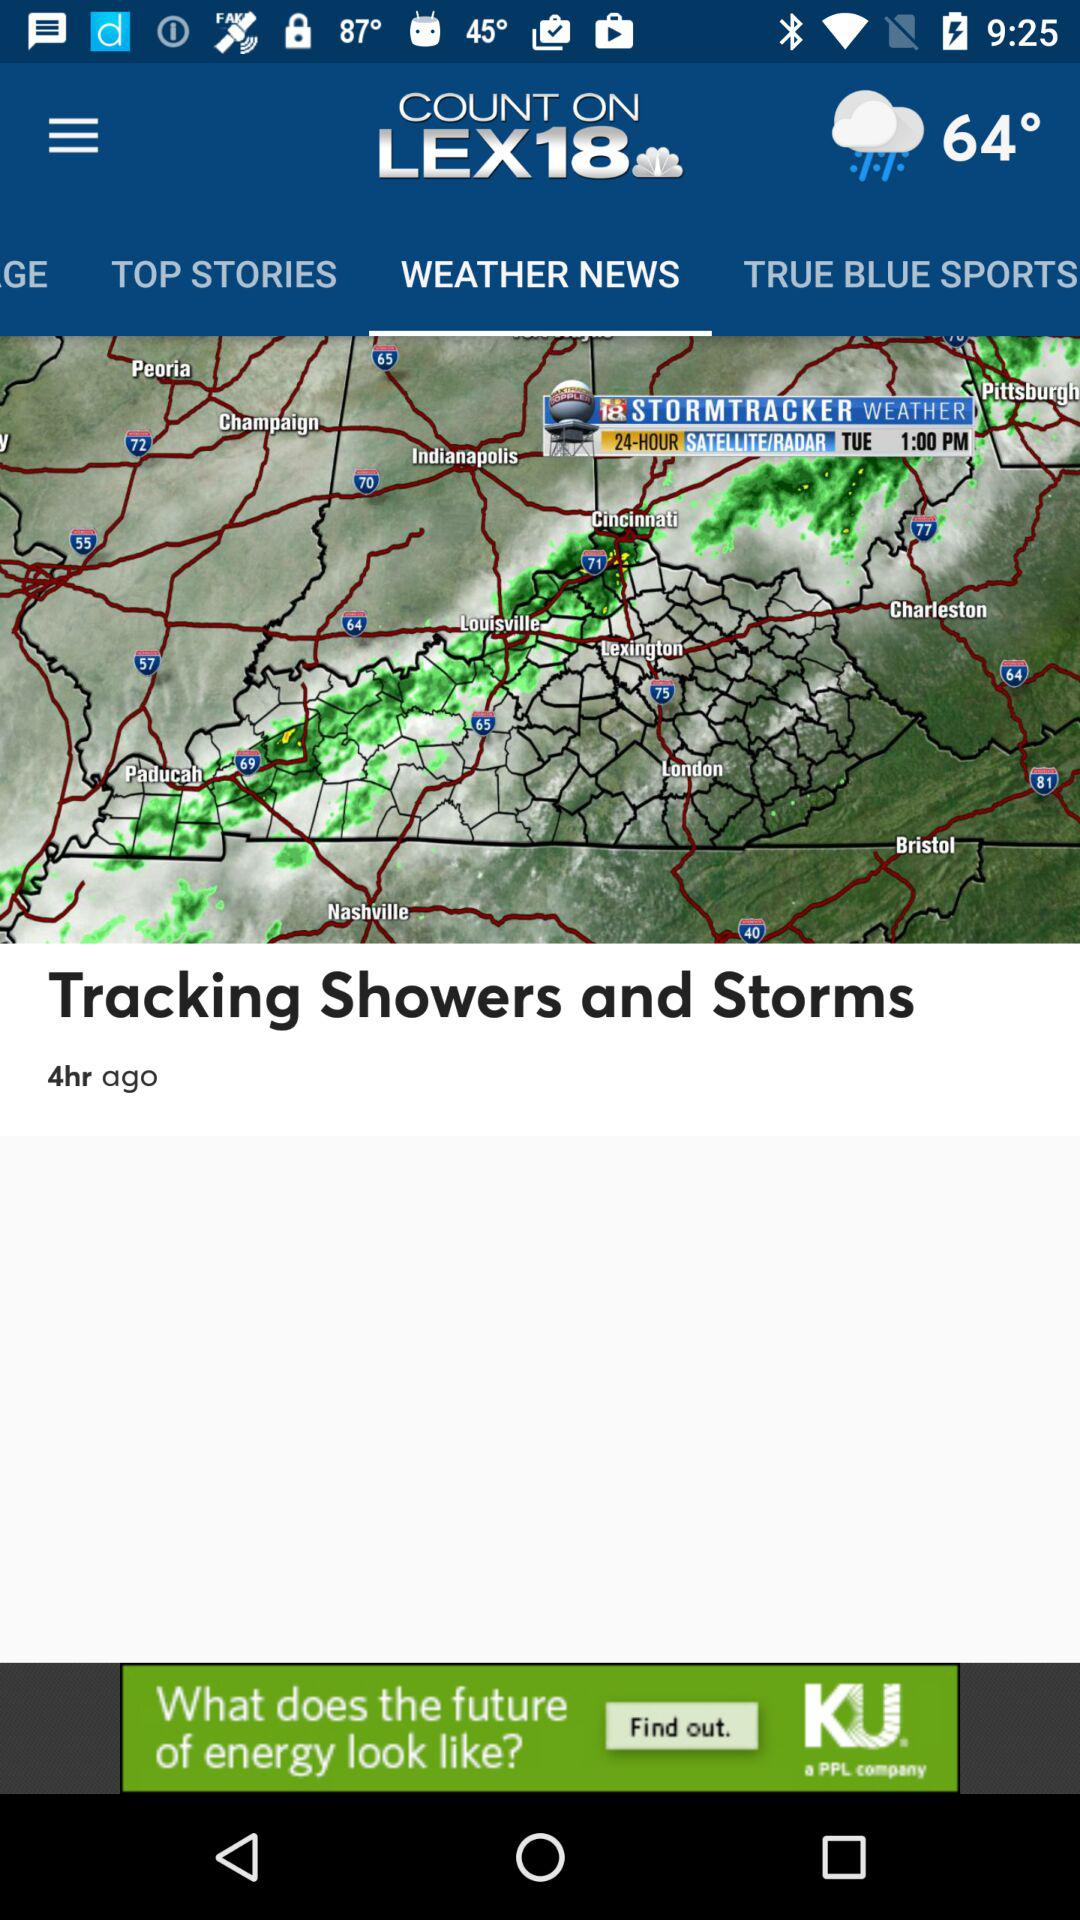Which tab am I on? You are on the tab "WEATHER NEWS". 